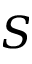Convert formula to latex. <formula><loc_0><loc_0><loc_500><loc_500>S</formula> 